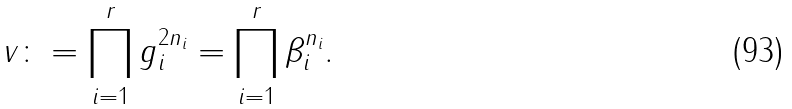Convert formula to latex. <formula><loc_0><loc_0><loc_500><loc_500>v \colon = \prod _ { i = 1 } ^ { r } g _ { i } ^ { 2 n _ { i } } = \prod _ { i = 1 } ^ { r } \beta _ { i } ^ { n _ { i } } .</formula> 